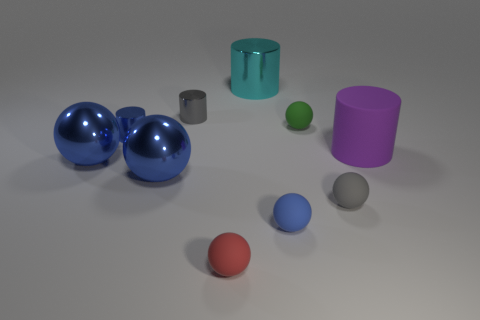Subtract all cyan cylinders. How many blue balls are left? 3 Subtract 1 cylinders. How many cylinders are left? 3 Subtract all gray balls. How many balls are left? 5 Subtract all tiny green spheres. How many spheres are left? 5 Subtract all cyan balls. Subtract all purple cylinders. How many balls are left? 6 Subtract all spheres. How many objects are left? 4 Add 6 tiny blue cylinders. How many tiny blue cylinders exist? 7 Subtract 1 red balls. How many objects are left? 9 Subtract all tiny cyan matte cubes. Subtract all big cyan cylinders. How many objects are left? 9 Add 2 green objects. How many green objects are left? 3 